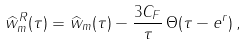<formula> <loc_0><loc_0><loc_500><loc_500>\widehat { w } _ { m } ^ { R } ( \tau ) = \widehat { w } _ { m } ( \tau ) - { \frac { 3 C _ { F } } { \tau } } \, \Theta ( \tau - e ^ { r } ) \, ,</formula> 